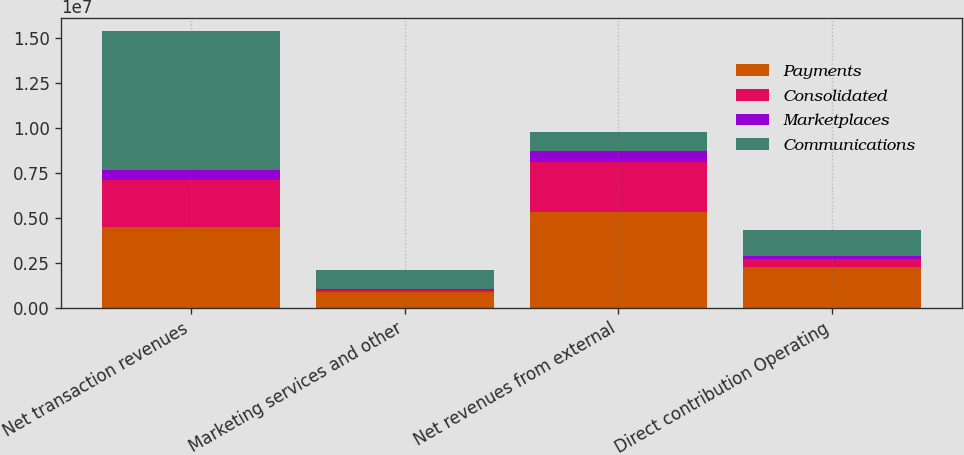<chart> <loc_0><loc_0><loc_500><loc_500><stacked_bar_chart><ecel><fcel>Net transaction revenues<fcel>Marketing services and other<fcel>Net revenues from external<fcel>Direct contribution Operating<nl><fcel>Payments<fcel>4.46184e+06<fcel>849169<fcel>5.31101e+06<fcel>2.25192e+06<nl><fcel>Consolidated<fcel>2.64119e+06<fcel>154751<fcel>2.79594e+06<fcel>463382<nl><fcel>Marketplaces<fcel>575096<fcel>45307<fcel>620403<fcel>157702<nl><fcel>Communications<fcel>7.67814e+06<fcel>1.04923e+06<fcel>1.04923e+06<fcel>1.41624e+06<nl></chart> 